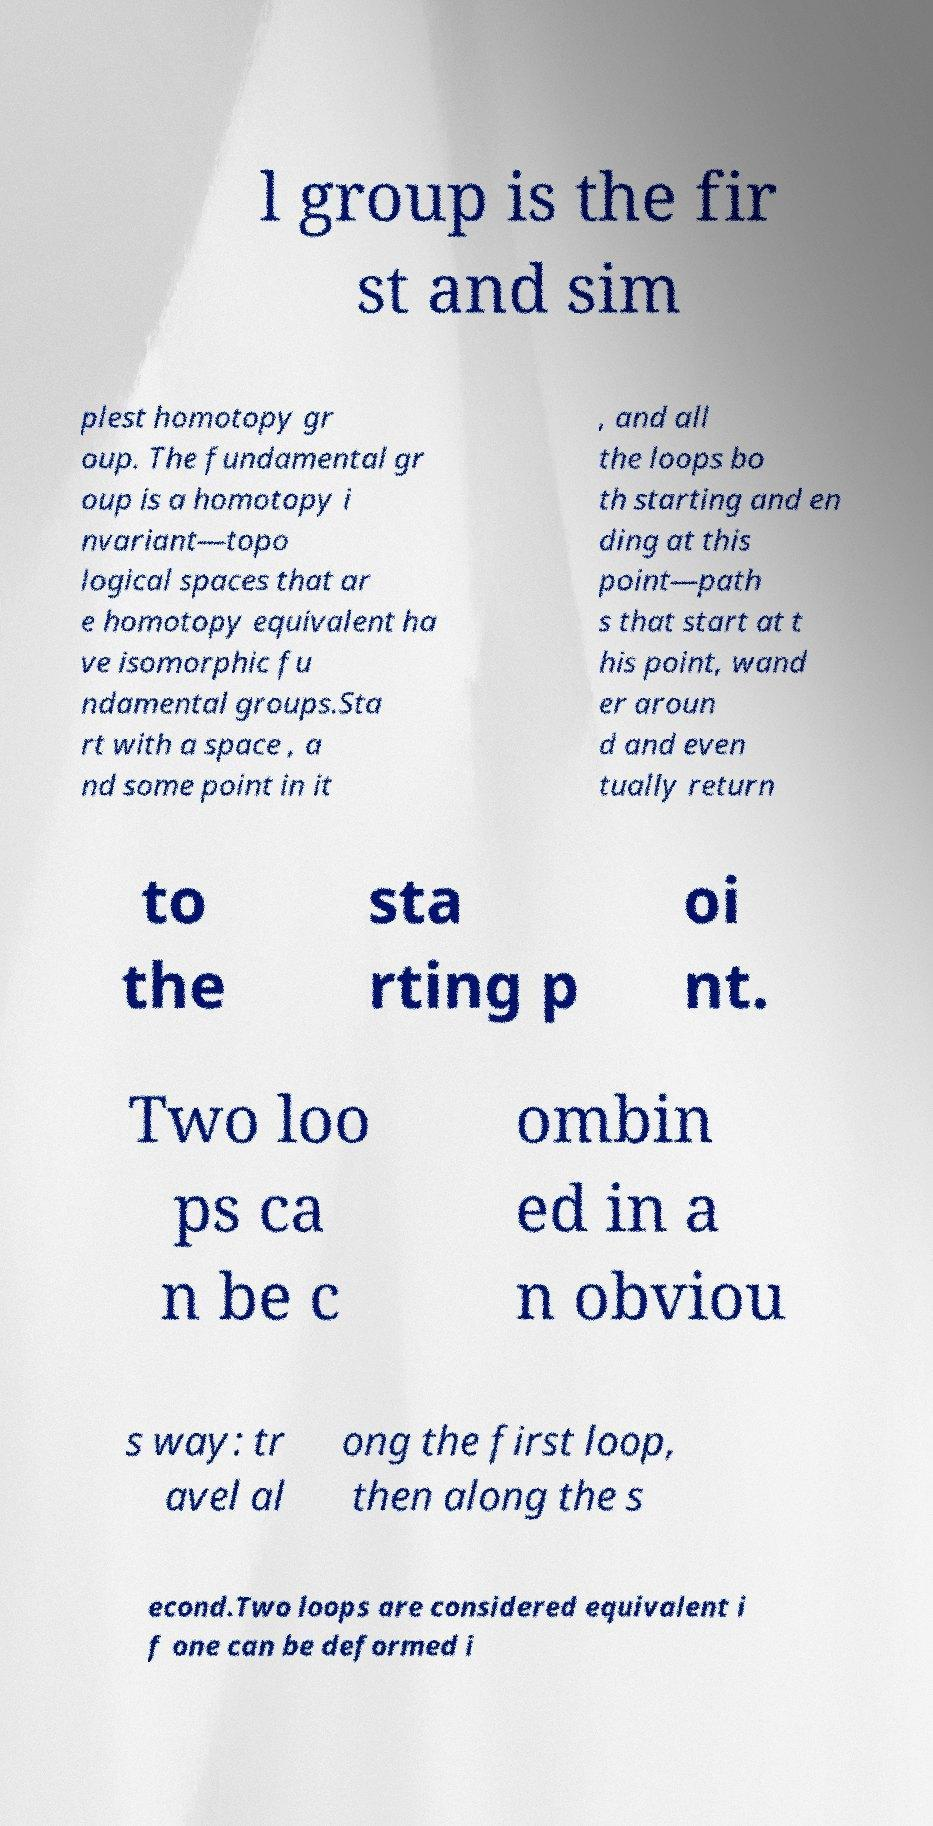There's text embedded in this image that I need extracted. Can you transcribe it verbatim? l group is the fir st and sim plest homotopy gr oup. The fundamental gr oup is a homotopy i nvariant—topo logical spaces that ar e homotopy equivalent ha ve isomorphic fu ndamental groups.Sta rt with a space , a nd some point in it , and all the loops bo th starting and en ding at this point—path s that start at t his point, wand er aroun d and even tually return to the sta rting p oi nt. Two loo ps ca n be c ombin ed in a n obviou s way: tr avel al ong the first loop, then along the s econd.Two loops are considered equivalent i f one can be deformed i 